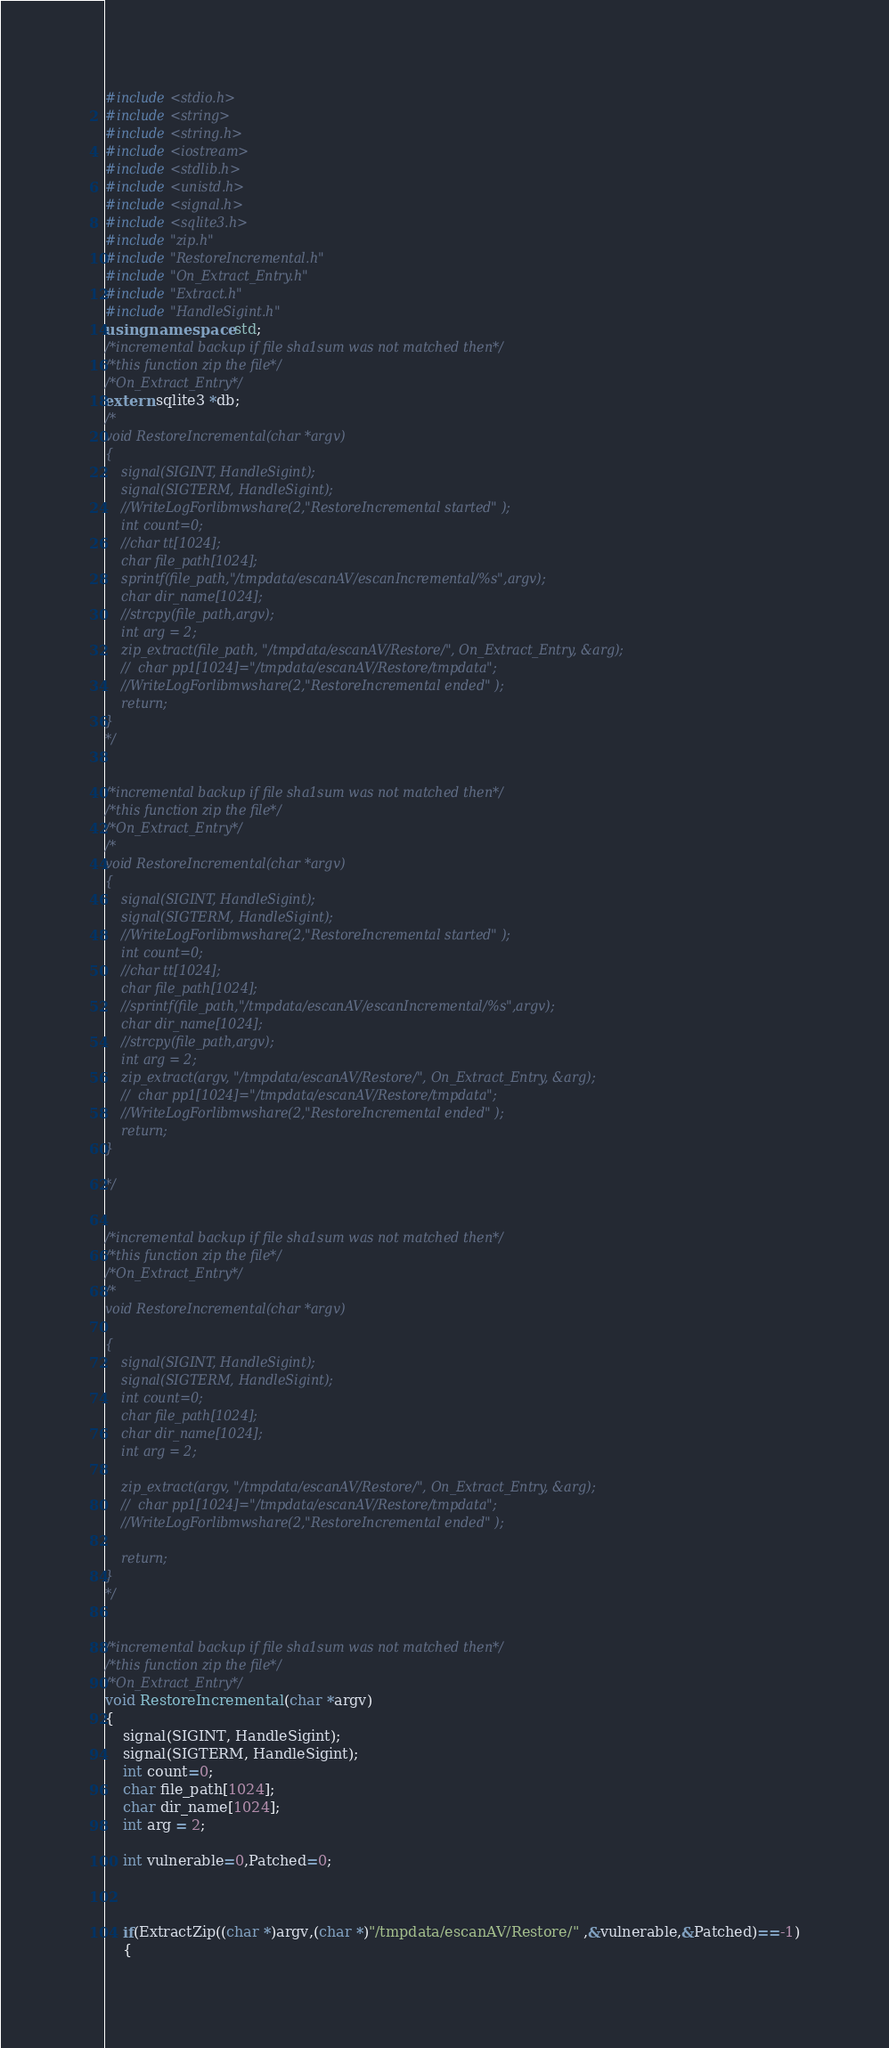Convert code to text. <code><loc_0><loc_0><loc_500><loc_500><_C++_>#include<stdio.h>
#include<string>
#include<string.h>
#include<iostream>
#include<stdlib.h>
#include<unistd.h>
#include<signal.h>
#include<sqlite3.h>
#include"zip.h"
#include"RestoreIncremental.h"
#include"On_Extract_Entry.h"
#include"Extract.h"
#include"HandleSigint.h"
using namespace std;
/*incremental backup if file sha1sum was not matched then*/
/*this function zip the file*/
/*On_Extract_Entry*/
extern sqlite3 *db;
/*
void RestoreIncremental(char *argv)
{
	signal(SIGINT, HandleSigint);
	signal(SIGTERM, HandleSigint);
	//WriteLogForlibmwshare(2,"RestoreIncremental started" );
	int count=0;
	//char tt[1024];
	char file_path[1024];
	sprintf(file_path,"/tmpdata/escanAV/escanIncremental/%s",argv);
	char dir_name[1024];
	//strcpy(file_path,argv);
	int arg = 2;
	zip_extract(file_path, "/tmpdata/escanAV/Restore/", On_Extract_Entry, &arg);
	//	char pp1[1024]="/tmpdata/escanAV/Restore/tmpdata";
	//WriteLogForlibmwshare(2,"RestoreIncremental ended" );
	return;
}
*/


/*incremental backup if file sha1sum was not matched then*/
/*this function zip the file*/
/*On_Extract_Entry*/
/*
void RestoreIncremental(char *argv)
{
	signal(SIGINT, HandleSigint);
	signal(SIGTERM, HandleSigint);
	//WriteLogForlibmwshare(2,"RestoreIncremental started" );
	int count=0;
	//char tt[1024];
	char file_path[1024];
	//sprintf(file_path,"/tmpdata/escanAV/escanIncremental/%s",argv);
	char dir_name[1024];
	//strcpy(file_path,argv);
	int arg = 2;
	zip_extract(argv, "/tmpdata/escanAV/Restore/", On_Extract_Entry, &arg);
	//	char pp1[1024]="/tmpdata/escanAV/Restore/tmpdata";
	//WriteLogForlibmwshare(2,"RestoreIncremental ended" );
	return;
}

*/


/*incremental backup if file sha1sum was not matched then*/
/*this function zip the file*/
/*On_Extract_Entry*/
/*
void RestoreIncremental(char *argv)

{
	signal(SIGINT, HandleSigint);
	signal(SIGTERM, HandleSigint);
	int count=0;
	char file_path[1024];
	char dir_name[1024];
	int arg = 2;
	
	zip_extract(argv, "/tmpdata/escanAV/Restore/", On_Extract_Entry, &arg);
	//	char pp1[1024]="/tmpdata/escanAV/Restore/tmpdata";
	//WriteLogForlibmwshare(2,"RestoreIncremental ended" );
	
	return;
}
*/


/*incremental backup if file sha1sum was not matched then*/
/*this function zip the file*/
/*On_Extract_Entry*/
void RestoreIncremental(char *argv)
{
	signal(SIGINT, HandleSigint);
	signal(SIGTERM, HandleSigint);
	int count=0;
	char file_path[1024];
	char dir_name[1024];
	int arg = 2;

	int vulnerable=0,Patched=0;
	


	if(ExtractZip((char *)argv,(char *)"/tmpdata/escanAV/Restore/" ,&vulnerable,&Patched)==-1)
	{</code> 